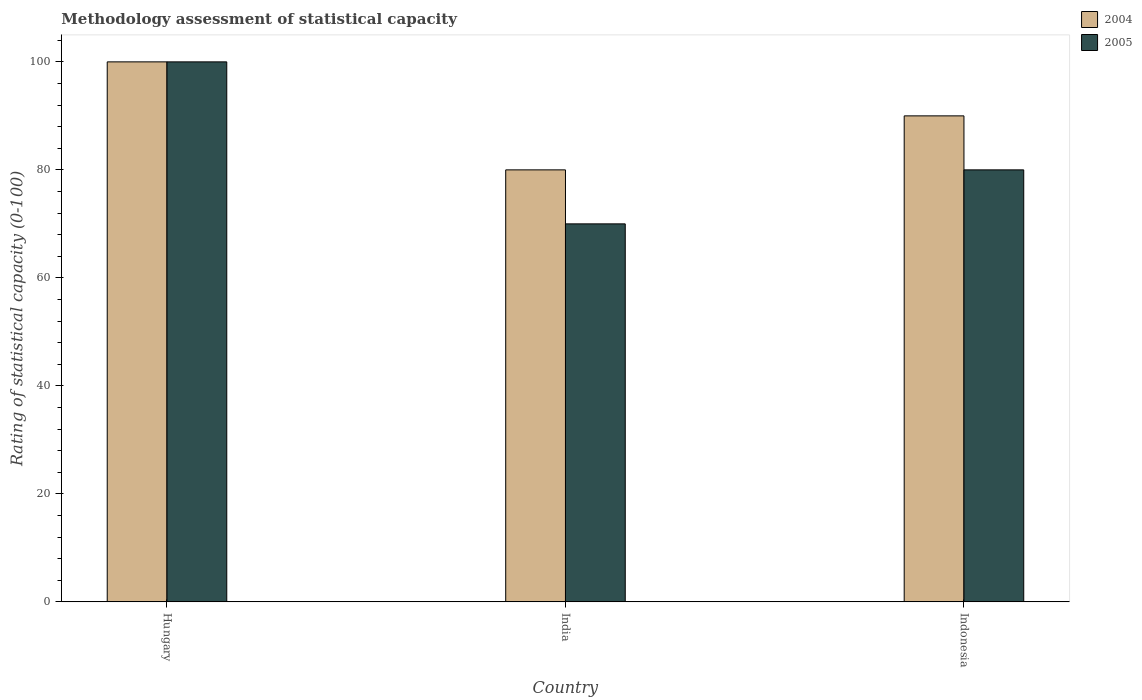How many different coloured bars are there?
Provide a succinct answer. 2. Are the number of bars per tick equal to the number of legend labels?
Give a very brief answer. Yes. Are the number of bars on each tick of the X-axis equal?
Your answer should be very brief. Yes. How many bars are there on the 2nd tick from the left?
Your answer should be compact. 2. In which country was the rating of statistical capacity in 2004 maximum?
Your response must be concise. Hungary. In which country was the rating of statistical capacity in 2005 minimum?
Offer a very short reply. India. What is the total rating of statistical capacity in 2004 in the graph?
Your answer should be very brief. 270. What is the difference between the rating of statistical capacity in 2004 in India and that in Indonesia?
Give a very brief answer. -10. What is the difference between the rating of statistical capacity in 2004 in Hungary and the rating of statistical capacity in 2005 in Indonesia?
Ensure brevity in your answer.  20. What is the average rating of statistical capacity in 2005 per country?
Offer a terse response. 83.33. In how many countries, is the rating of statistical capacity in 2005 greater than 40?
Keep it short and to the point. 3. What is the ratio of the rating of statistical capacity in 2004 in India to that in Indonesia?
Offer a terse response. 0.89. Is the rating of statistical capacity in 2004 in India less than that in Indonesia?
Your answer should be very brief. Yes. In how many countries, is the rating of statistical capacity in 2005 greater than the average rating of statistical capacity in 2005 taken over all countries?
Offer a very short reply. 1. Is the sum of the rating of statistical capacity in 2004 in India and Indonesia greater than the maximum rating of statistical capacity in 2005 across all countries?
Your answer should be compact. Yes. What does the 2nd bar from the right in India represents?
Your response must be concise. 2004. How many bars are there?
Provide a short and direct response. 6. Are all the bars in the graph horizontal?
Provide a short and direct response. No. Are the values on the major ticks of Y-axis written in scientific E-notation?
Your answer should be compact. No. Does the graph contain grids?
Offer a very short reply. No. What is the title of the graph?
Keep it short and to the point. Methodology assessment of statistical capacity. Does "2004" appear as one of the legend labels in the graph?
Your answer should be very brief. Yes. What is the label or title of the Y-axis?
Make the answer very short. Rating of statistical capacity (0-100). What is the Rating of statistical capacity (0-100) of 2005 in India?
Provide a short and direct response. 70. What is the Rating of statistical capacity (0-100) in 2004 in Indonesia?
Make the answer very short. 90. Across all countries, what is the maximum Rating of statistical capacity (0-100) in 2004?
Keep it short and to the point. 100. Across all countries, what is the maximum Rating of statistical capacity (0-100) of 2005?
Your answer should be compact. 100. Across all countries, what is the minimum Rating of statistical capacity (0-100) in 2004?
Ensure brevity in your answer.  80. Across all countries, what is the minimum Rating of statistical capacity (0-100) of 2005?
Provide a succinct answer. 70. What is the total Rating of statistical capacity (0-100) in 2004 in the graph?
Give a very brief answer. 270. What is the total Rating of statistical capacity (0-100) of 2005 in the graph?
Offer a very short reply. 250. What is the difference between the Rating of statistical capacity (0-100) of 2005 in Hungary and that in Indonesia?
Offer a very short reply. 20. What is the difference between the Rating of statistical capacity (0-100) of 2005 in India and that in Indonesia?
Offer a very short reply. -10. What is the difference between the Rating of statistical capacity (0-100) in 2004 in India and the Rating of statistical capacity (0-100) in 2005 in Indonesia?
Ensure brevity in your answer.  0. What is the average Rating of statistical capacity (0-100) in 2004 per country?
Keep it short and to the point. 90. What is the average Rating of statistical capacity (0-100) in 2005 per country?
Make the answer very short. 83.33. What is the difference between the Rating of statistical capacity (0-100) in 2004 and Rating of statistical capacity (0-100) in 2005 in Hungary?
Keep it short and to the point. 0. What is the difference between the Rating of statistical capacity (0-100) in 2004 and Rating of statistical capacity (0-100) in 2005 in India?
Make the answer very short. 10. What is the ratio of the Rating of statistical capacity (0-100) of 2004 in Hungary to that in India?
Provide a succinct answer. 1.25. What is the ratio of the Rating of statistical capacity (0-100) in 2005 in Hungary to that in India?
Offer a terse response. 1.43. What is the ratio of the Rating of statistical capacity (0-100) in 2005 in India to that in Indonesia?
Offer a very short reply. 0.88. What is the difference between the highest and the second highest Rating of statistical capacity (0-100) in 2004?
Ensure brevity in your answer.  10. What is the difference between the highest and the lowest Rating of statistical capacity (0-100) in 2004?
Your answer should be compact. 20. 